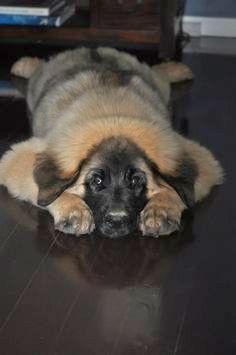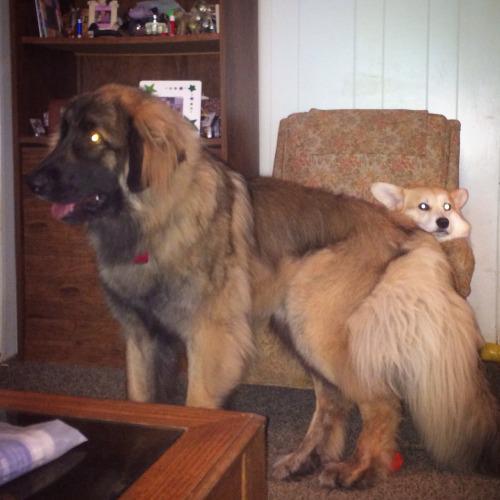The first image is the image on the left, the second image is the image on the right. For the images shown, is this caption "A dog is looking to the left" true? Answer yes or no. Yes. The first image is the image on the left, the second image is the image on the right. For the images displayed, is the sentence "One of the dogs is laying down with its head on the floor." factually correct? Answer yes or no. Yes. 